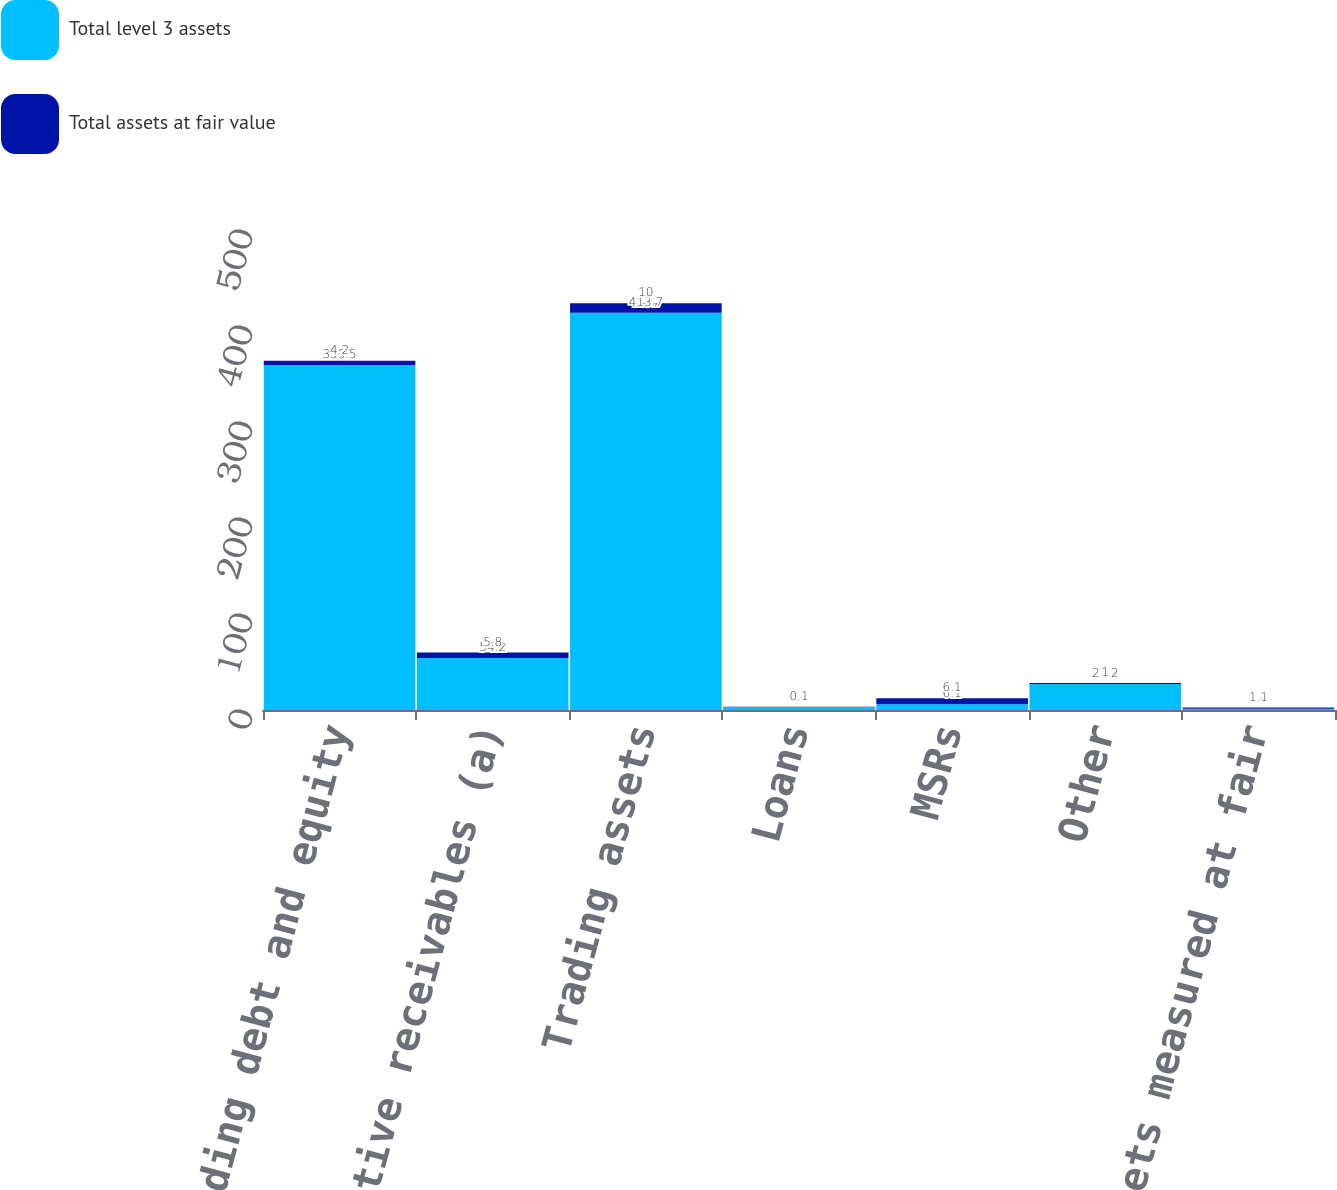<chart> <loc_0><loc_0><loc_500><loc_500><stacked_bar_chart><ecel><fcel>Trading debt and equity<fcel>Derivative receivables (a)<fcel>Trading assets<fcel>Loans<fcel>MSRs<fcel>Other<fcel>Total assets measured at fair<nl><fcel>Total level 3 assets<fcel>359.5<fcel>54.2<fcel>413.7<fcel>3.2<fcel>6.1<fcel>27.2<fcel>1.4<nl><fcel>Total assets at fair value<fcel>4.2<fcel>5.8<fcel>10<fcel>0.1<fcel>6.1<fcel>1<fcel>1.1<nl></chart> 